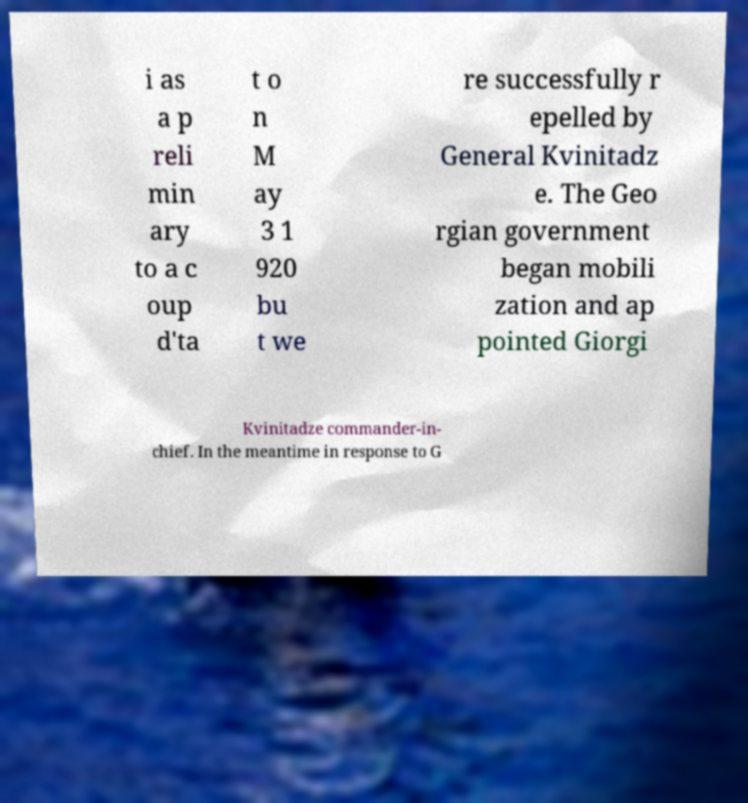There's text embedded in this image that I need extracted. Can you transcribe it verbatim? i as a p reli min ary to a c oup d'ta t o n M ay 3 1 920 bu t we re successfully r epelled by General Kvinitadz e. The Geo rgian government began mobili zation and ap pointed Giorgi Kvinitadze commander-in- chief. In the meantime in response to G 